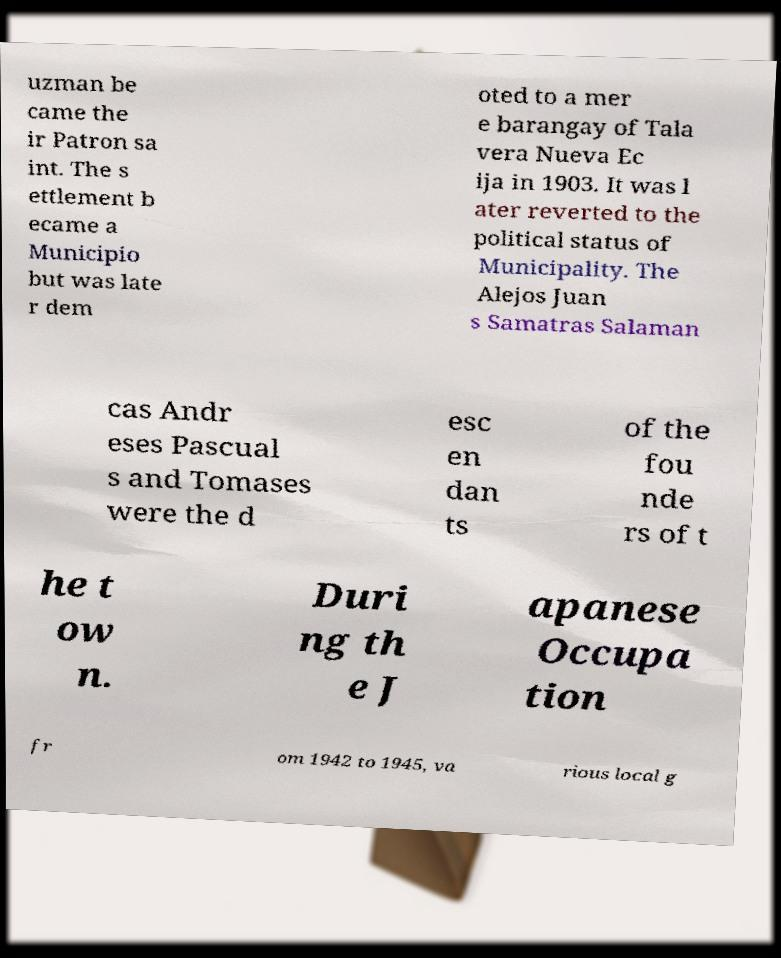Could you assist in decoding the text presented in this image and type it out clearly? uzman be came the ir Patron sa int. The s ettlement b ecame a Municipio but was late r dem oted to a mer e barangay of Tala vera Nueva Ec ija in 1903. It was l ater reverted to the political status of Municipality. The Alejos Juan s Samatras Salaman cas Andr eses Pascual s and Tomases were the d esc en dan ts of the fou nde rs of t he t ow n. Duri ng th e J apanese Occupa tion fr om 1942 to 1945, va rious local g 